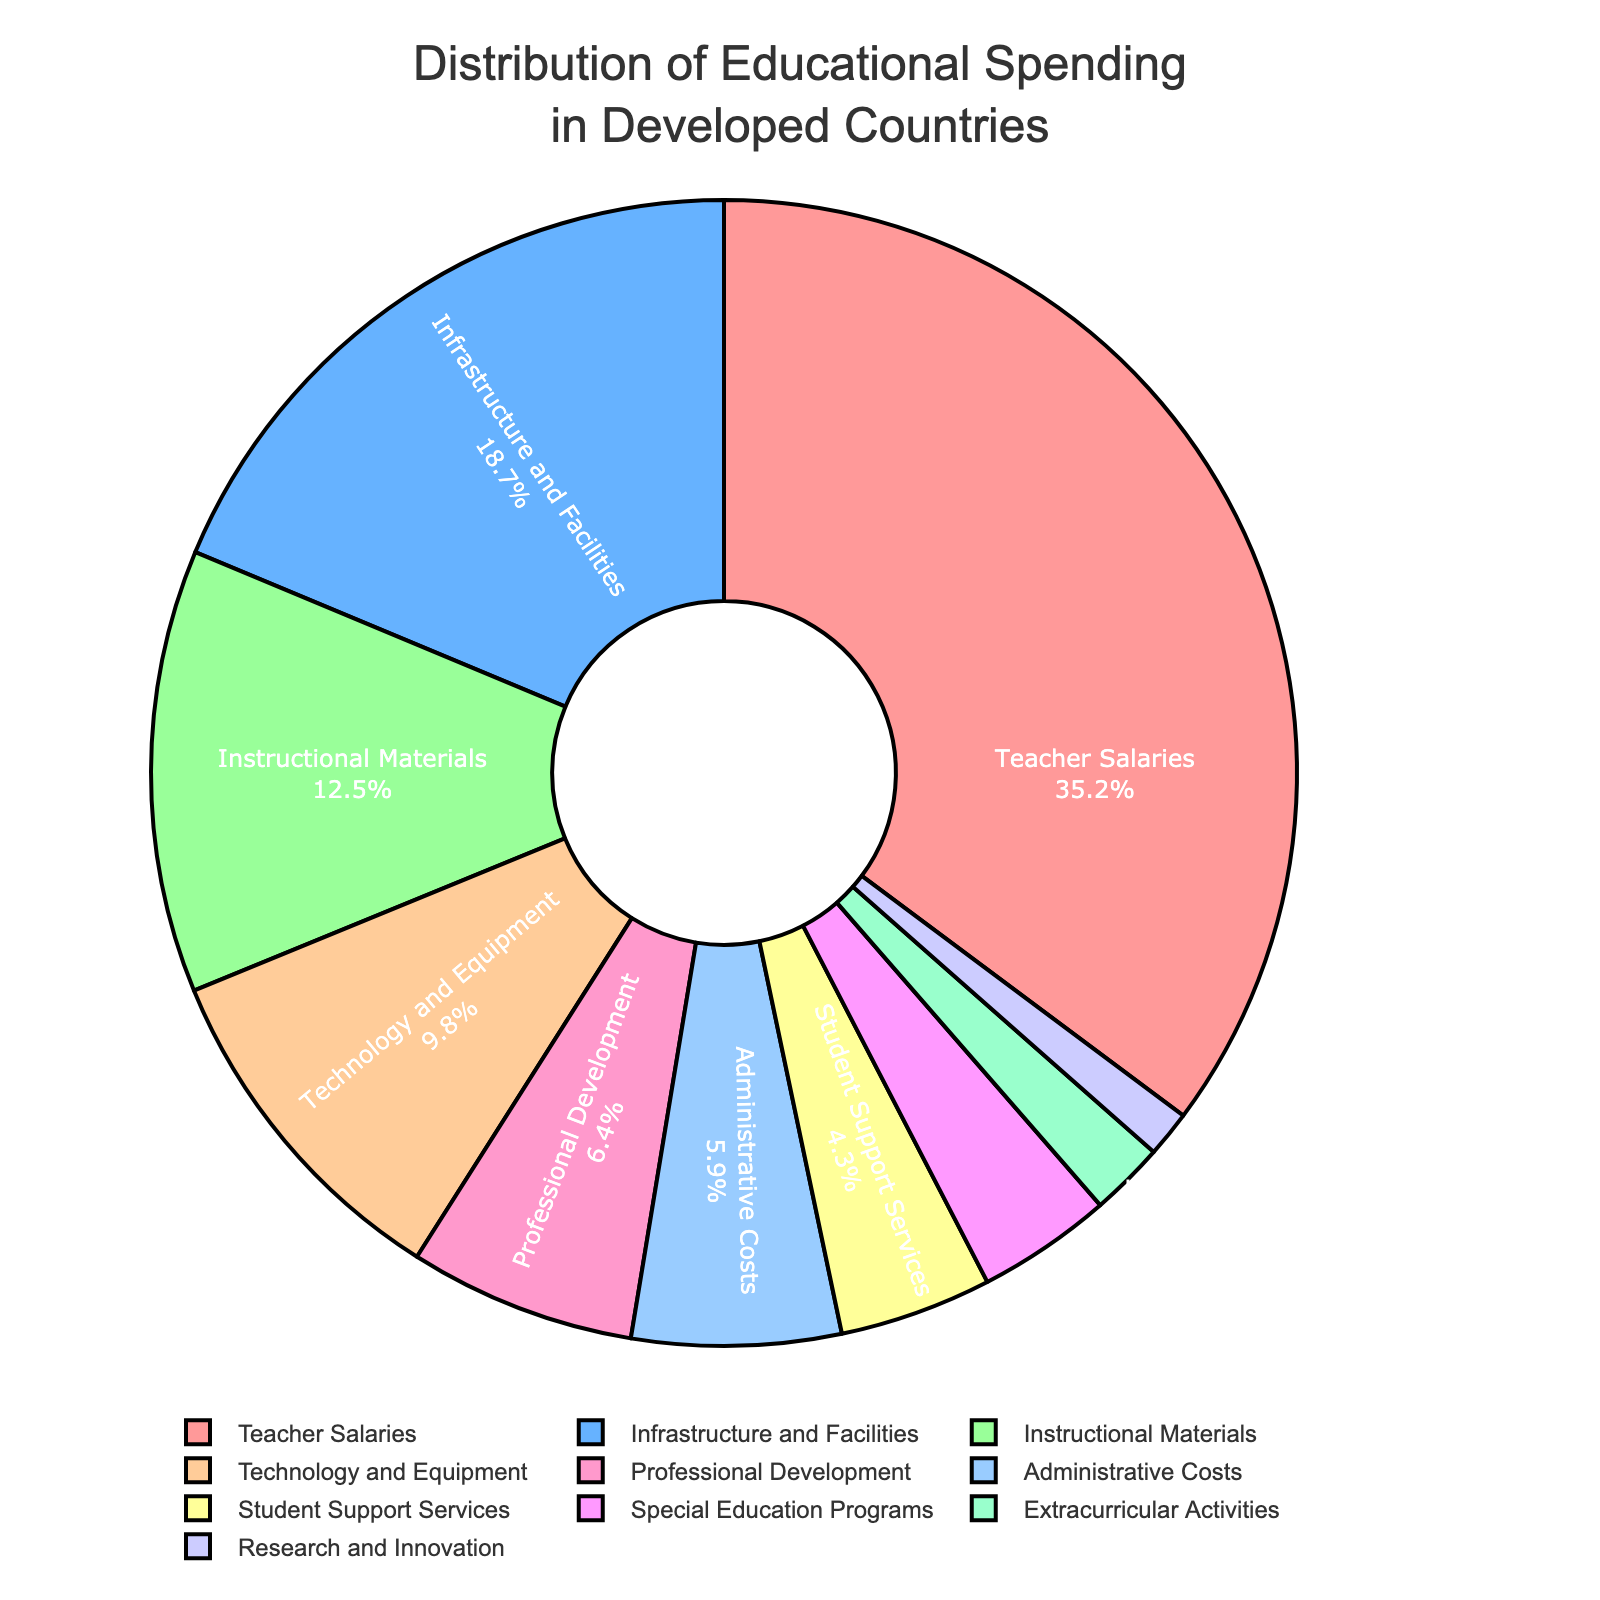What percentage of educational spending is allocated to Teacher Salaries? Teacher Salaries account for 35.2% of the total educational spending. This can be seen from the section labeled 'Teacher Salaries' on the pie chart.
Answer: 35.2% Which category receives more funding: Technology and Equipment or Professional Development? Technology and Equipment receive 9.8% while Professional Development receives 6.4% of the spending. By comparing these two values, Technology and Equipment receive more funding.
Answer: Technology and Equipment How much more percentage is spent on Infrastructure and Facilities compared to Instructional Materials? Infrastructure and Facilities receive 18.7% of the spending, whereas Instructional Materials receive 12.5%. The difference can be calculated as 18.7% - 12.5%, which is 6.2%.
Answer: 6.2% What is the total percentage of spending on Administrative Costs and Student Support Services combined? Administrative Costs account for 5.9% and Student Support Services for 4.3%. By adding these two percentages, the total is 5.9% + 4.3% = 10.2%.
Answer: 10.2% Among the categories, which receives the least funding and what is its percentage? Research and Innovation receives the least funding with a percentage of 1.3%. This can be seen from the smallest section in the pie chart labeled 'Research and Innovation’.
Answer: Research and Innovation, 1.3% Is the percentage of spending on Special Education Programs greater than the percentage spent on Extracurricular Activities? Special Education Programs receive 3.8% of the spending while Extracurricular Activities receive 2.1%. Since 3.8% > 2.1%, Special Education Programs receive a greater percentage.
Answer: Yes What is the combined percentage of spending for categories with less than 5% allocation? The categories with less than 5% allocation are: Student Support Services (4.3%), Special Education Programs (3.8%), Extracurricular Activities (2.1%), and Research and Innovation (1.3%). Adding these percentages gives 4.3% + 3.8% + 2.1% + 1.3% = 11.5%.
Answer: 11.5% Which category is assigned a green color in the pie chart? The Instructional Materials category is assigned a green color, as can be visually observed in the pie chart.
Answer: Instructional Materials What is the difference in funding percentages between Administrative Costs and Extracurricular Activities? Administrative Costs are allocated 5.9% and Extracurricular Activities 2.1%. The difference is 5.9% - 2.1% = 3.8%.
Answer: 3.8% Are Teacher Salaries allocated more than three times the percentage given to Professional Development? Teacher Salaries receive 35.2% while Professional Development receives 6.4%. Three times 6.4% is 19.2%. Since 35.2% > 19.2%, the allocation for Teacher Salaries is more than three times that of Professional Development.
Answer: Yes 